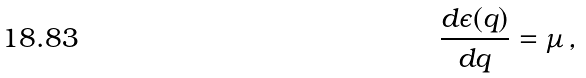<formula> <loc_0><loc_0><loc_500><loc_500>\frac { d \epsilon ( q ) } { d q } = \mu \, ,</formula> 